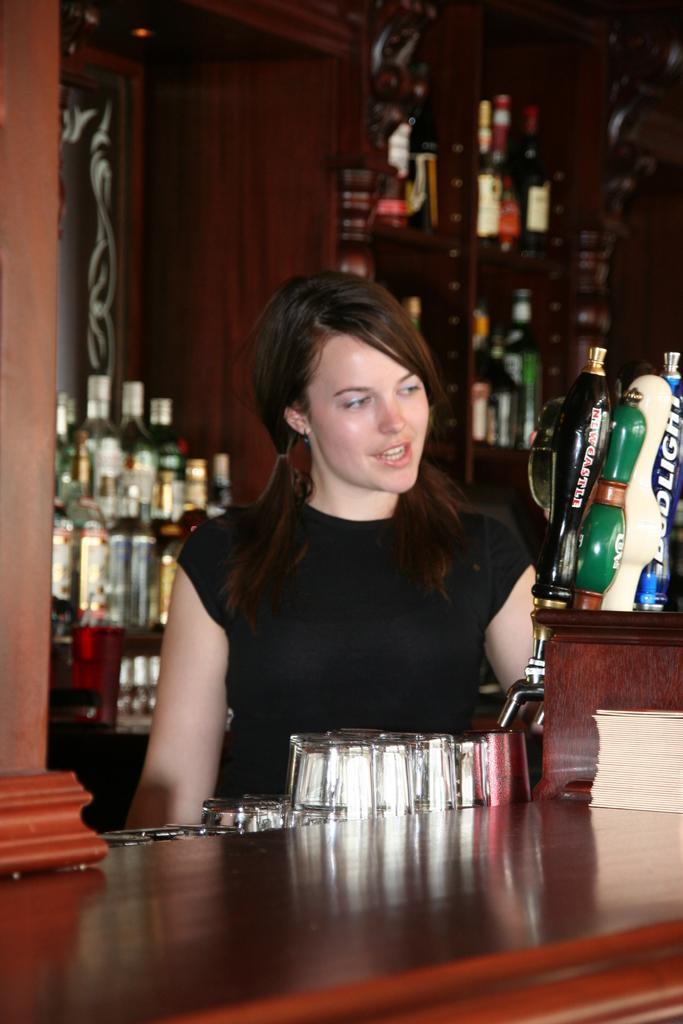In one or two sentences, can you explain what this image depicts? This is the picture of the inside of the wine shop. There is a table. There is a glass on a table. She is smiling we can her mouth is open. We can see in the background there is a cup board. There is a cupboard wine bottles on a cupboard. 